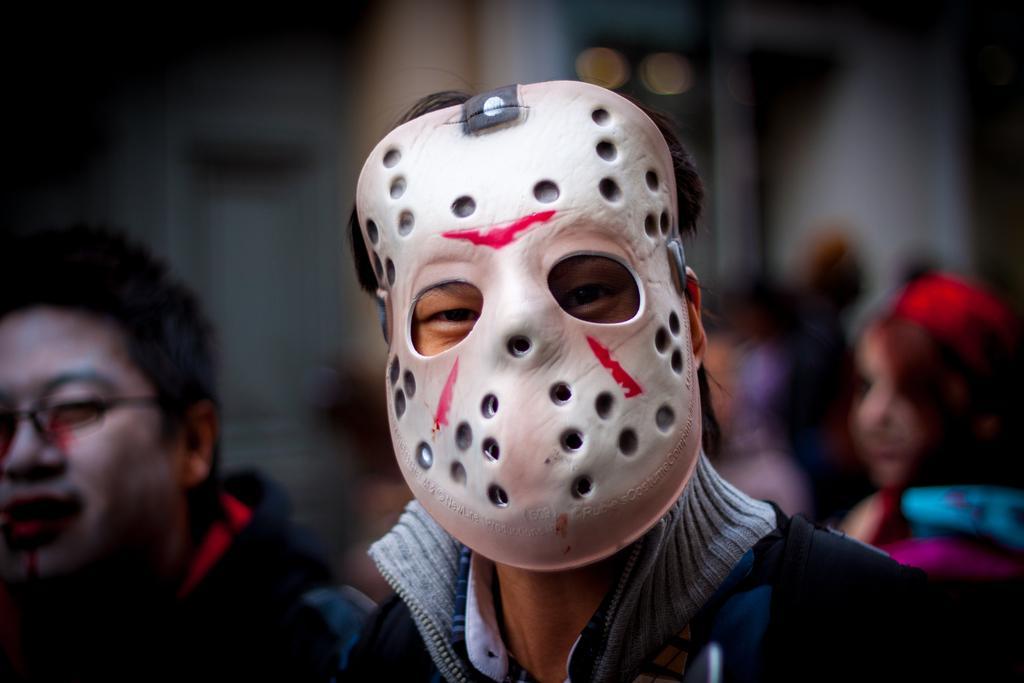Could you give a brief overview of what you see in this image? In this image I can see few people and here I can see a person is wearing white colour mask. I can also see this image is little bit blurry from background. 